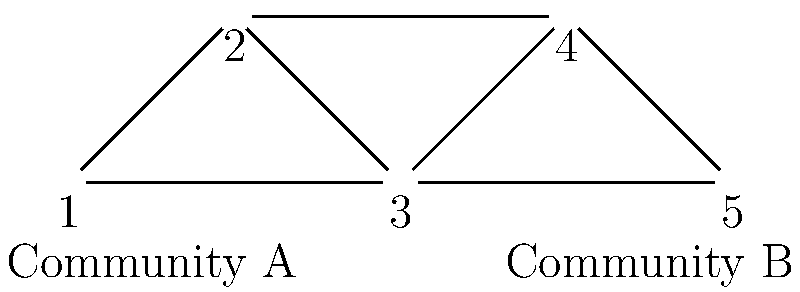In the graph above, nodes represent startups and edges represent shared investors. Two distinct communities (A and B) have been identified. Using the concept of modularity in community detection, which startup's reassignment to the opposite community would most likely increase the overall modularity of the network? To answer this question, we need to understand modularity and how it relates to community detection:

1. Modularity measures the strength of division of a network into communities. Higher modularity indicates better community structure.

2. Modularity increases when there are more edges within communities than expected by chance.

3. To maximize modularity, we want to minimize inter-community edges and maximize intra-community edges.

4. Looking at the graph:
   - Community A consists of nodes 1, 2, and 3
   - Community B consists of nodes 4 and 5

5. Analyzing each node:
   - Node 1: Has 2 intra-community edges and 0 inter-community edges
   - Node 2: Has 2 intra-community edges and 1 inter-community edge
   - Node 3: Has 2 intra-community edges and 1 inter-community edge
   - Node 4: Has 1 intra-community edge and 1 inter-community edge
   - Node 5: Has 1 intra-community edge and 1 inter-community edge

6. Moving node 3 to Community B would:
   - Reduce 2 intra-community edges in A
   - Increase 1 intra-community edge in B
   - Turn 1 inter-community edge into an intra-community edge

7. Moving node 4 to Community A would:
   - Increase 2 intra-community edges in A
   - Reduce 1 intra-community edge in B
   - Turn 1 inter-community edge into an intra-community edge

8. Node 4's reassignment would result in a higher increase in intra-community edges and a larger decrease in inter-community edges compared to any other node's reassignment.

Therefore, reassigning node 4 (startup 4) to Community A would most likely increase the overall modularity of the network.
Answer: Startup 4 